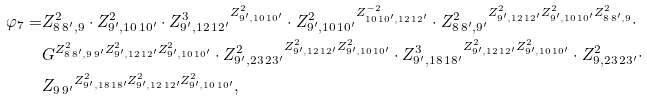<formula> <loc_0><loc_0><loc_500><loc_500>\varphi _ { 7 } = & Z ^ { 2 } _ { 8 \, 8 ^ { \prime } , 9 } \cdot Z ^ { 2 } _ { 9 ^ { \prime } , 1 0 \, 1 0 ^ { \prime } } \cdot { Z ^ { 3 } _ { 9 ^ { \prime } , 1 2 \, 1 2 ^ { \prime } } } ^ { Z ^ { 2 } _ { 9 ^ { \prime } , 1 0 \, 1 0 ^ { \prime } } } \cdot { Z ^ { 2 } _ { 9 ^ { \prime } , 1 0 \, 1 0 ^ { \prime } } } ^ { Z ^ { - 2 } _ { 1 0 \, 1 0 ^ { \prime } , 1 2 \, 1 2 ^ { \prime } } } \cdot { Z ^ { 2 } _ { 8 \, 8 ^ { \prime } , 9 ^ { \prime } } } ^ { Z ^ { 2 } _ { 9 ^ { \prime } , 1 2 \, 1 2 ^ { \prime } } Z ^ { 2 } _ { 9 ^ { \prime } , 1 0 \, 1 0 ^ { \prime } } Z ^ { 2 } _ { 8 \, 8 ^ { \prime } , 9 } } \cdot \\ & G ^ { Z ^ { 2 } _ { 8 \, 8 ^ { \prime } , 9 \, 9 ^ { \prime } } Z ^ { 2 } _ { 9 ^ { \prime } , 1 2 \, 1 2 ^ { \prime } } Z ^ { 2 } _ { 9 ^ { \prime } , 1 0 \, 1 0 ^ { \prime } } } \cdot { Z ^ { 2 } _ { 9 ^ { \prime } , 2 3 \, 2 3 ^ { \prime } } } ^ { Z ^ { 2 } _ { 9 ^ { \prime } , 1 2 \, 1 2 ^ { \prime } } Z ^ { 2 } _ { 9 ^ { \prime } , 1 0 \, 1 0 ^ { \prime } } } \cdot { Z ^ { 3 } _ { 9 ^ { \prime } , 1 8 \, 1 8 ^ { \prime } } } ^ { Z ^ { 2 } _ { 9 ^ { \prime } , 1 2 \, 1 2 ^ { \prime } } Z ^ { 2 } _ { 9 ^ { \prime } , 1 0 \, 1 0 ^ { \prime } } } \cdot Z ^ { 2 } _ { 9 , 2 3 \, 2 3 ^ { \prime } } \cdot \\ & { Z _ { 9 \, 9 ^ { \prime } } } ^ { Z ^ { 2 } _ { 9 ^ { \prime } , 1 8 \, 1 8 ^ { \prime } } Z ^ { 2 } _ { 9 ^ { \prime } , 1 2 \, 1 2 ^ { \prime } } Z ^ { 2 } _ { 9 ^ { \prime } , 1 0 \, 1 0 ^ { \prime } } } ,</formula> 